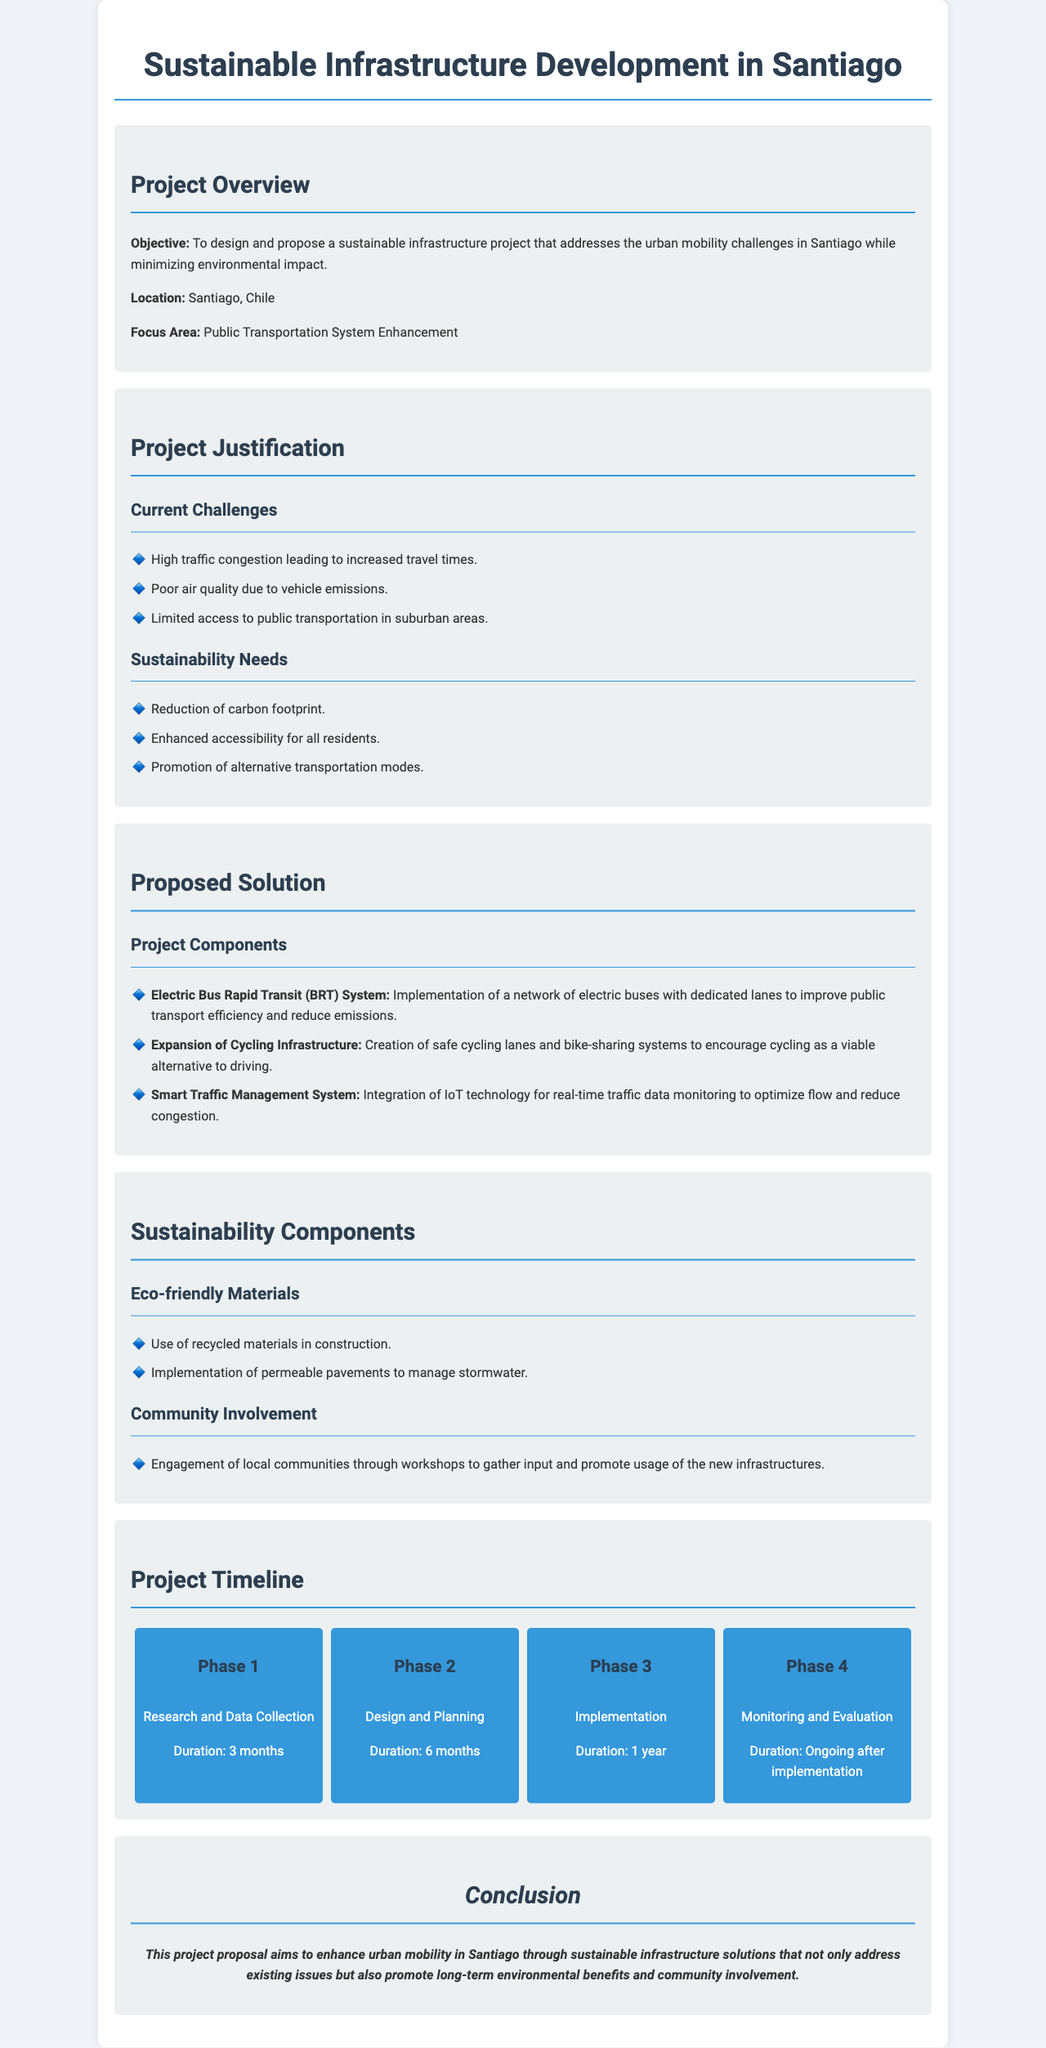What is the project objective? The objective is to design and propose a sustainable infrastructure project that addresses the urban mobility challenges in Santiago while minimizing environmental impact.
Answer: To design and propose a sustainable infrastructure project that addresses the urban mobility challenges in Santiago while minimizing environmental impact What is the focus area of the project? The document states that the focus area is related to enhancing public transportation systems.
Answer: Public Transportation System Enhancement How long is the implementation phase? The implementation phase is specified in the project timeline as lasting 1 year.
Answer: 1 year What type of transport system is proposed? The document mentions the implementation of an electric bus rapid transit system as a key component.
Answer: Electric Bus Rapid Transit (BRT) System What are the sustainability needs addressed? The identified needs include reduction of carbon footprint, enhanced accessibility, and promotion of alternative transportation modes.
Answer: Reduction of carbon footprint, enhanced accessibility for all residents, promotion of alternative transportation modes What community involvement strategy is mentioned? The proposal includes engagement of local communities through workshops to gather input and promote usage of the new infrastructures.
Answer: Engagement of local communities through workshops What is the duration of the research and data collection phase? The timeline specifies that this phase lasts for 3 months.
Answer: 3 months What is one of the eco-friendly materials suggested for construction? The document states that recycled materials are to be used in the construction process.
Answer: Recycled materials 